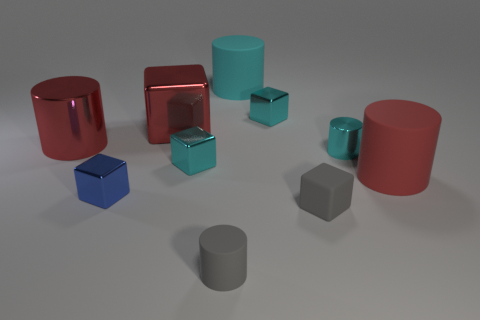Subtract 1 cubes. How many cubes are left? 4 Subtract all gray cylinders. How many cylinders are left? 4 Subtract all tiny blue shiny cubes. How many cubes are left? 4 Subtract all yellow cubes. Subtract all blue cylinders. How many cubes are left? 5 Subtract all large red shiny cylinders. Subtract all big cylinders. How many objects are left? 6 Add 6 cyan metal cylinders. How many cyan metal cylinders are left? 7 Add 6 large brown things. How many large brown things exist? 6 Subtract 0 blue cylinders. How many objects are left? 10 